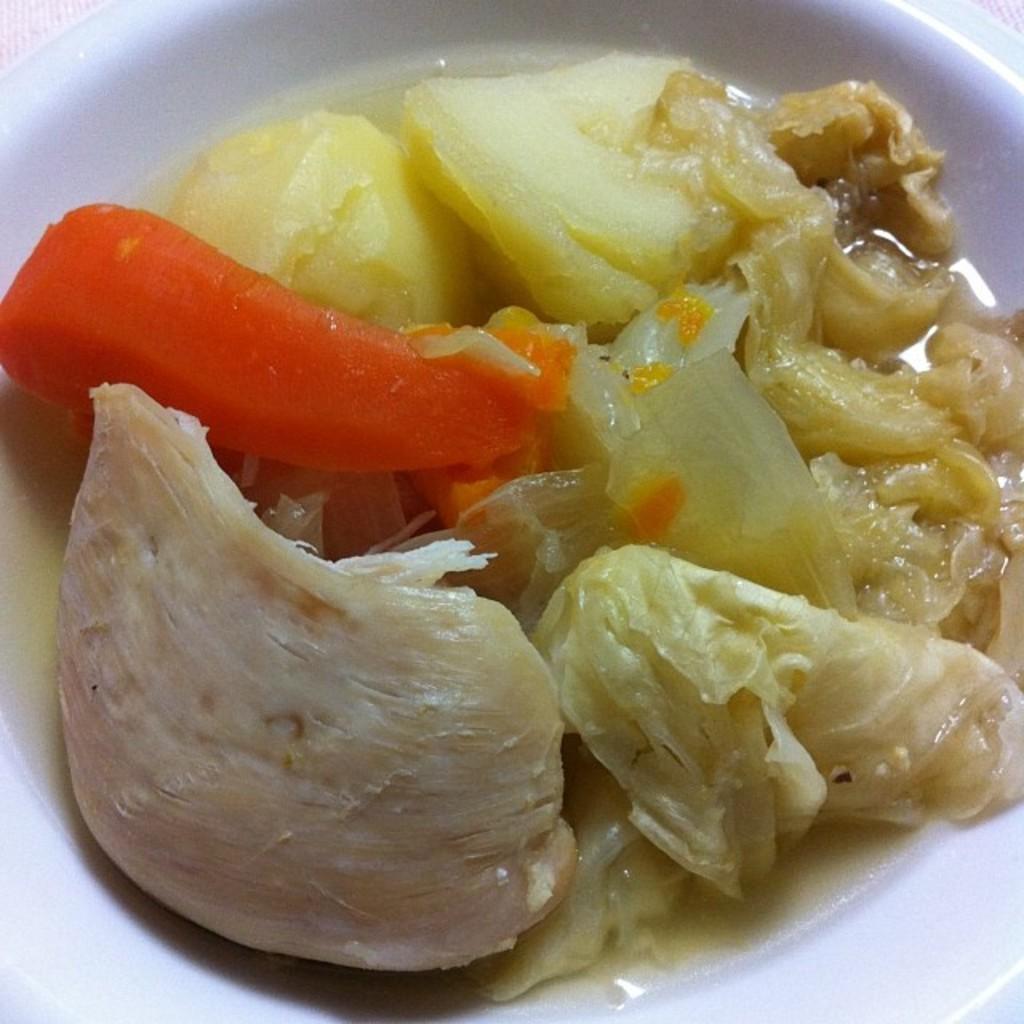Could you give a brief overview of what you see in this image? In the image we can see bowl, in the bowl we can see food item and boiled carrot and potatoes. 